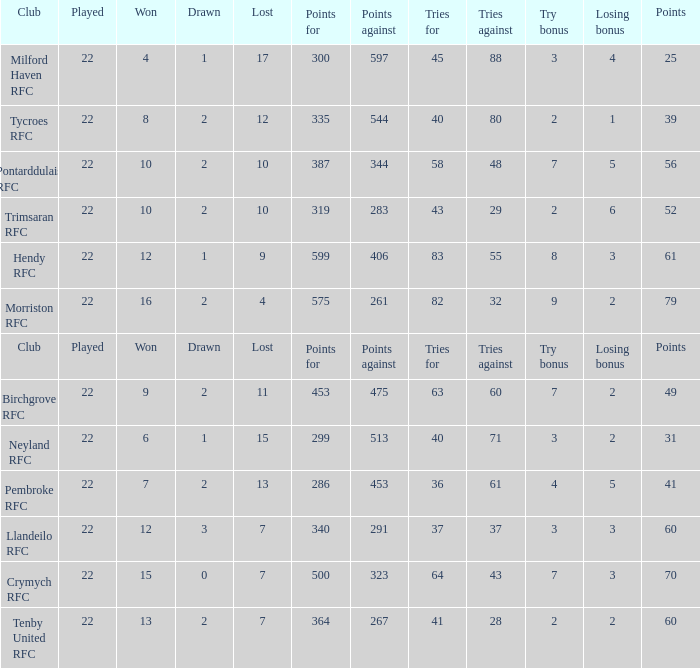What's the won with try bonus being 8 12.0. 